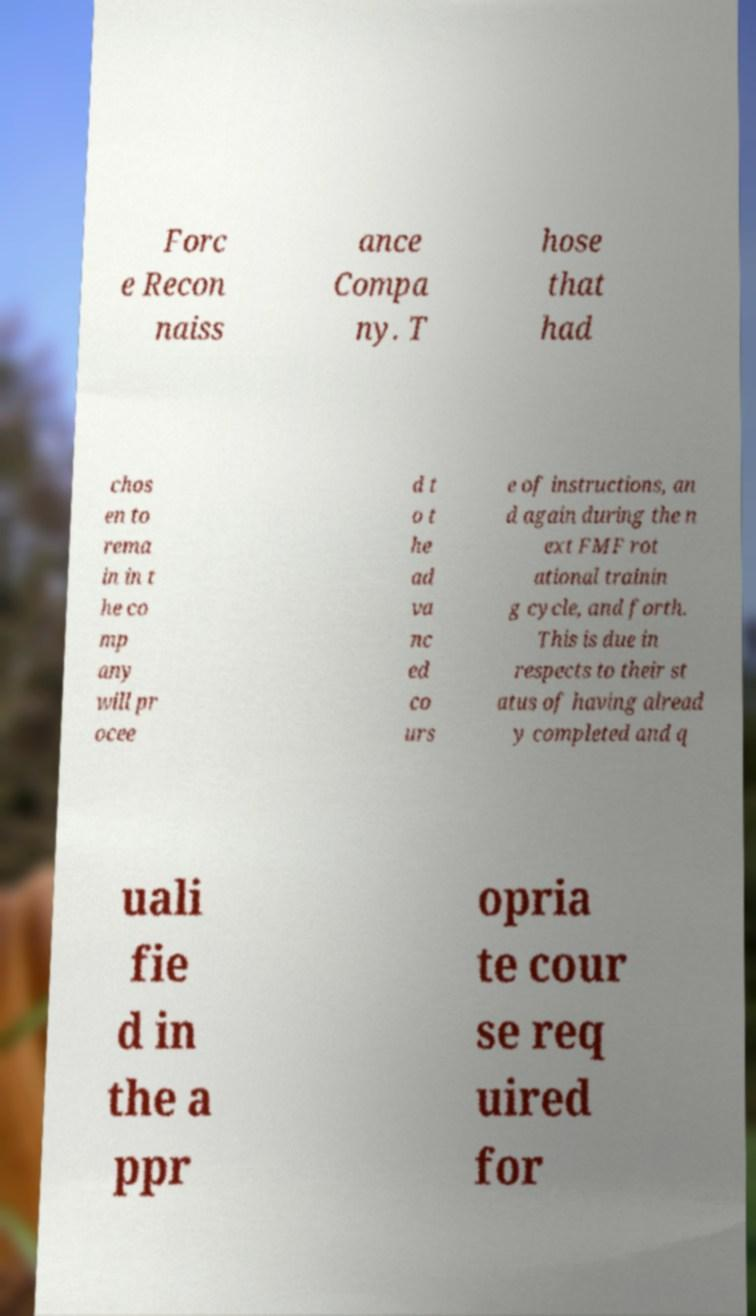Please read and relay the text visible in this image. What does it say? Forc e Recon naiss ance Compa ny. T hose that had chos en to rema in in t he co mp any will pr ocee d t o t he ad va nc ed co urs e of instructions, an d again during the n ext FMF rot ational trainin g cycle, and forth. This is due in respects to their st atus of having alread y completed and q uali fie d in the a ppr opria te cour se req uired for 